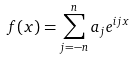Convert formula to latex. <formula><loc_0><loc_0><loc_500><loc_500>f ( x ) = \sum _ { j = - n } ^ { n } a _ { j } e ^ { i j x }</formula> 